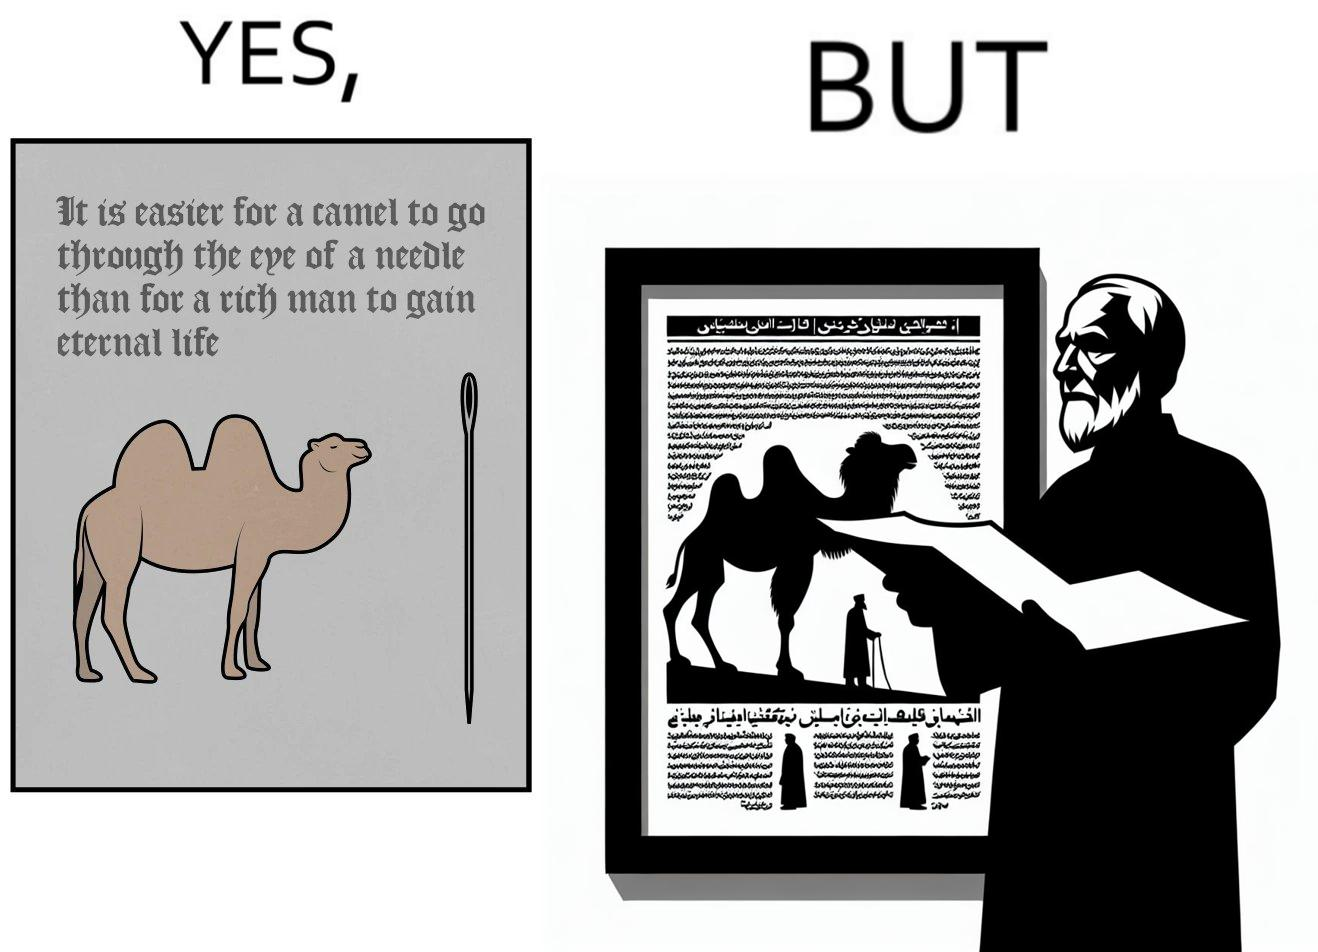Why is this image considered satirical? The image is ironic, because an old man with good looking clothes, symbolising him as rich, is showing a quote on the difficulty for a rich man to gain eternal life whereas the man has both long life meaning eternal life and good clothes meaning rich 